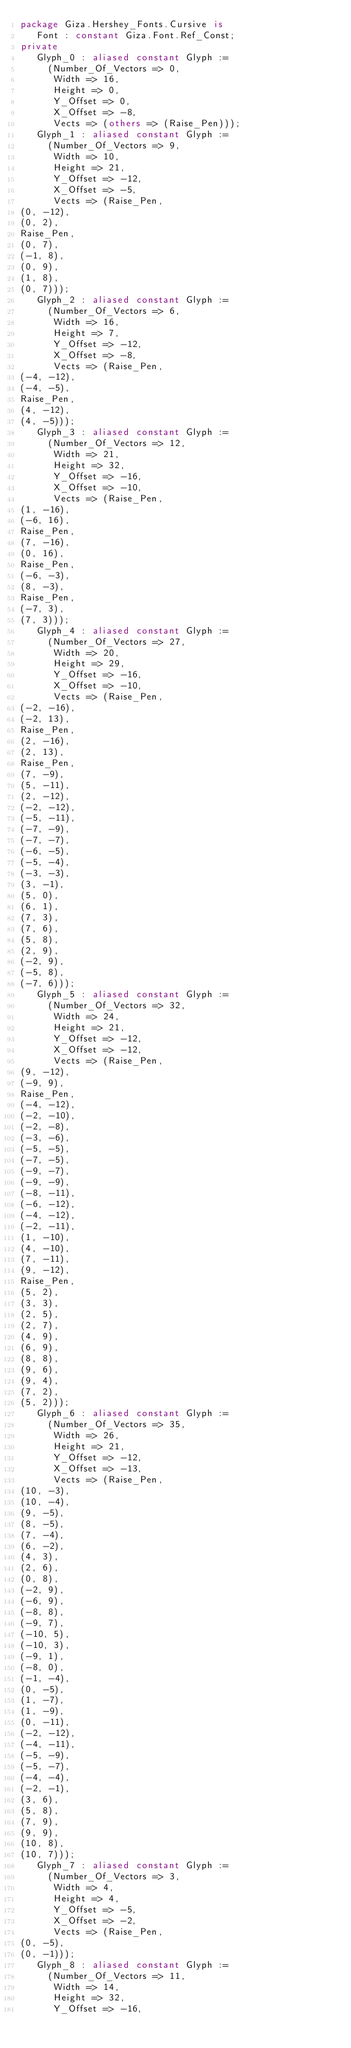Convert code to text. <code><loc_0><loc_0><loc_500><loc_500><_Ada_>package Giza.Hershey_Fonts.Cursive is
   Font : constant Giza.Font.Ref_Const;
private
   Glyph_0 : aliased constant Glyph :=
     (Number_Of_Vectors => 0,
      Width => 16,
      Height => 0,
      Y_Offset => 0,
      X_Offset => -8,
      Vects => (others => (Raise_Pen)));
   Glyph_1 : aliased constant Glyph :=
     (Number_Of_Vectors => 9,
      Width => 10,
      Height => 21,
      Y_Offset => -12,
      X_Offset => -5,
      Vects => (Raise_Pen,
(0, -12),
(0, 2),
Raise_Pen,
(0, 7),
(-1, 8),
(0, 9),
(1, 8),
(0, 7)));
   Glyph_2 : aliased constant Glyph :=
     (Number_Of_Vectors => 6,
      Width => 16,
      Height => 7,
      Y_Offset => -12,
      X_Offset => -8,
      Vects => (Raise_Pen,
(-4, -12),
(-4, -5),
Raise_Pen,
(4, -12),
(4, -5)));
   Glyph_3 : aliased constant Glyph :=
     (Number_Of_Vectors => 12,
      Width => 21,
      Height => 32,
      Y_Offset => -16,
      X_Offset => -10,
      Vects => (Raise_Pen,
(1, -16),
(-6, 16),
Raise_Pen,
(7, -16),
(0, 16),
Raise_Pen,
(-6, -3),
(8, -3),
Raise_Pen,
(-7, 3),
(7, 3)));
   Glyph_4 : aliased constant Glyph :=
     (Number_Of_Vectors => 27,
      Width => 20,
      Height => 29,
      Y_Offset => -16,
      X_Offset => -10,
      Vects => (Raise_Pen,
(-2, -16),
(-2, 13),
Raise_Pen,
(2, -16),
(2, 13),
Raise_Pen,
(7, -9),
(5, -11),
(2, -12),
(-2, -12),
(-5, -11),
(-7, -9),
(-7, -7),
(-6, -5),
(-5, -4),
(-3, -3),
(3, -1),
(5, 0),
(6, 1),
(7, 3),
(7, 6),
(5, 8),
(2, 9),
(-2, 9),
(-5, 8),
(-7, 6)));
   Glyph_5 : aliased constant Glyph :=
     (Number_Of_Vectors => 32,
      Width => 24,
      Height => 21,
      Y_Offset => -12,
      X_Offset => -12,
      Vects => (Raise_Pen,
(9, -12),
(-9, 9),
Raise_Pen,
(-4, -12),
(-2, -10),
(-2, -8),
(-3, -6),
(-5, -5),
(-7, -5),
(-9, -7),
(-9, -9),
(-8, -11),
(-6, -12),
(-4, -12),
(-2, -11),
(1, -10),
(4, -10),
(7, -11),
(9, -12),
Raise_Pen,
(5, 2),
(3, 3),
(2, 5),
(2, 7),
(4, 9),
(6, 9),
(8, 8),
(9, 6),
(9, 4),
(7, 2),
(5, 2)));
   Glyph_6 : aliased constant Glyph :=
     (Number_Of_Vectors => 35,
      Width => 26,
      Height => 21,
      Y_Offset => -12,
      X_Offset => -13,
      Vects => (Raise_Pen,
(10, -3),
(10, -4),
(9, -5),
(8, -5),
(7, -4),
(6, -2),
(4, 3),
(2, 6),
(0, 8),
(-2, 9),
(-6, 9),
(-8, 8),
(-9, 7),
(-10, 5),
(-10, 3),
(-9, 1),
(-8, 0),
(-1, -4),
(0, -5),
(1, -7),
(1, -9),
(0, -11),
(-2, -12),
(-4, -11),
(-5, -9),
(-5, -7),
(-4, -4),
(-2, -1),
(3, 6),
(5, 8),
(7, 9),
(9, 9),
(10, 8),
(10, 7)));
   Glyph_7 : aliased constant Glyph :=
     (Number_Of_Vectors => 3,
      Width => 4,
      Height => 4,
      Y_Offset => -5,
      X_Offset => -2,
      Vects => (Raise_Pen,
(0, -5),
(0, -1)));
   Glyph_8 : aliased constant Glyph :=
     (Number_Of_Vectors => 11,
      Width => 14,
      Height => 32,
      Y_Offset => -16,</code> 